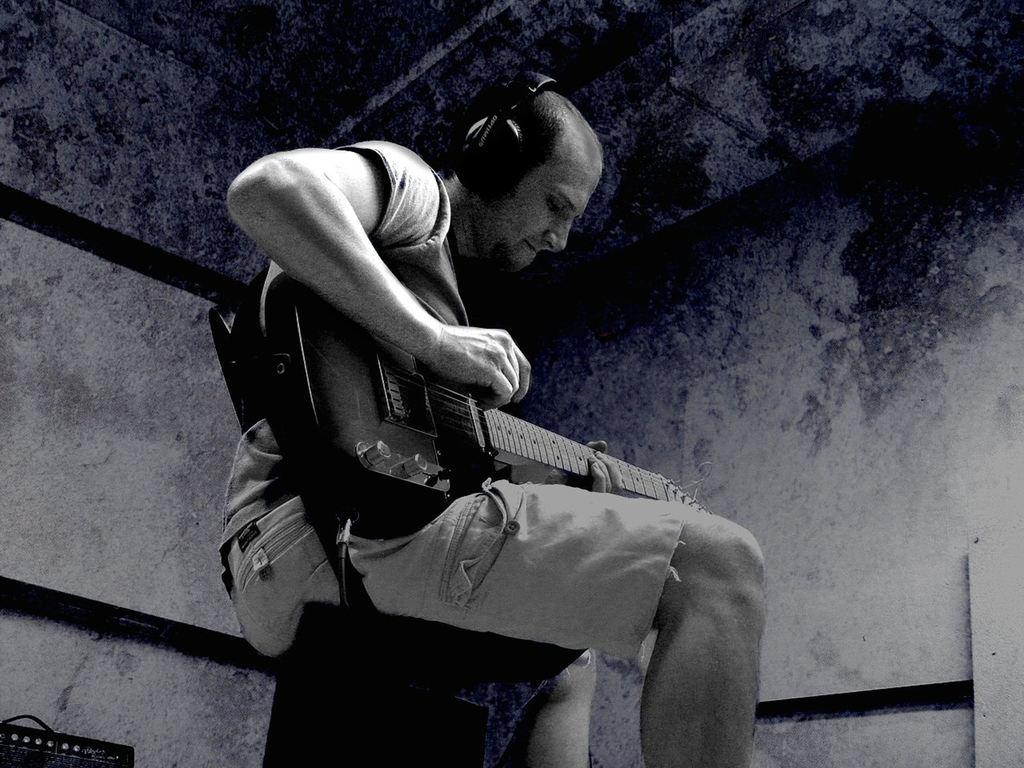Who is the main subject in the picture? There is a boy in the picture. What is the boy doing in the picture? The boy is sitting on a chair and playing the guitar. What is the boy wearing on his head? The boy has headphones on his head. What channel is the boy watching on the TV in the image? There is no TV present in the image, so it is not possible to determine what channel the boy might be watching. 